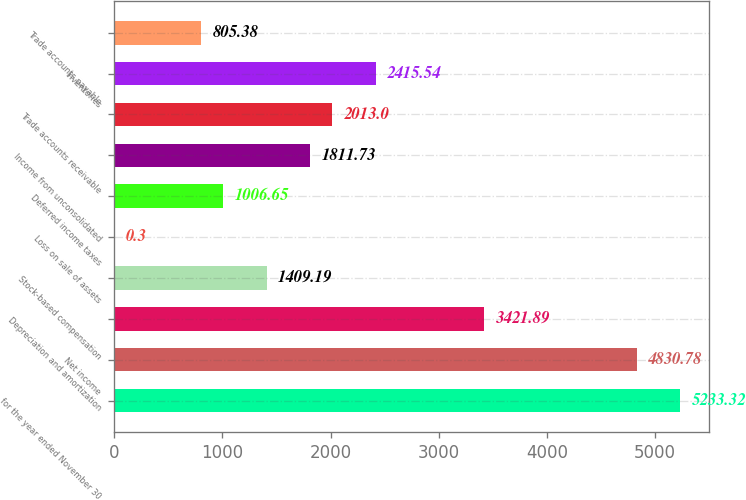<chart> <loc_0><loc_0><loc_500><loc_500><bar_chart><fcel>for the year ended November 30<fcel>Net income<fcel>Depreciation and amortization<fcel>Stock-based compensation<fcel>Loss on sale of assets<fcel>Deferred income taxes<fcel>Income from unconsolidated<fcel>Trade accounts receivable<fcel>Inventories<fcel>Trade accounts payable<nl><fcel>5233.32<fcel>4830.78<fcel>3421.89<fcel>1409.19<fcel>0.3<fcel>1006.65<fcel>1811.73<fcel>2013<fcel>2415.54<fcel>805.38<nl></chart> 